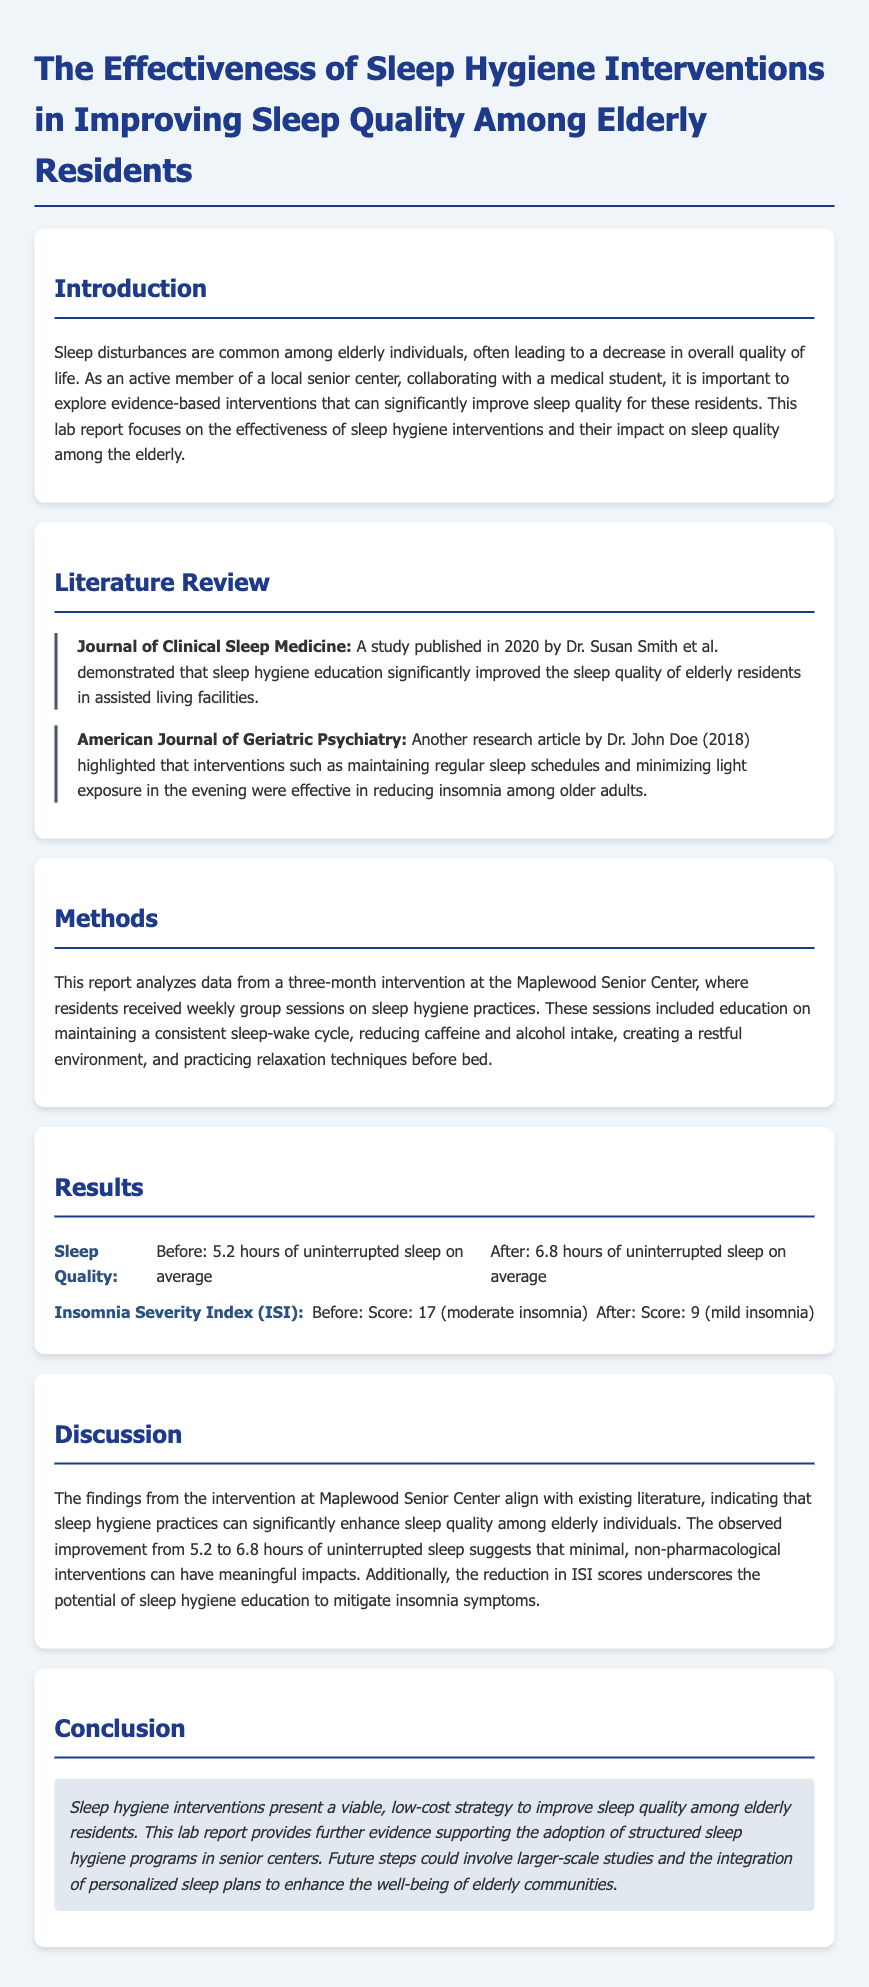What is the average hours of uninterrupted sleep before the intervention? The average hours of uninterrupted sleep before the intervention is stated in the results section of the document.
Answer: 5.2 hours What is the Insomnia Severity Index (ISI) score after the intervention? The ISI score after the intervention is detailed in the results section, which explains the change in insomnia severity.
Answer: 9 Who conducted the study published in the Journal of Clinical Sleep Medicine? The author of the study mentioned in the literature review is listed in the document.
Answer: Dr. Susan Smith What interventions were included in the sleep hygiene education? The methods section lists the specific interventions that were part of the sleep hygiene education during the sessions.
Answer: Consistent sleep-wake cycle, reducing caffeine and alcohol intake, creating a restful environment, relaxation techniques What is the main conclusion of the lab report? The conclusion summarizes the findings and overall implications of the research conducted.
Answer: Sleep hygiene interventions present a viable, low-cost strategy to improve sleep quality among elderly residents How long did the intervention at Maplewood Senior Center last? The duration of the intervention is stated in the methods section where it describes the study duration.
Answer: Three months 